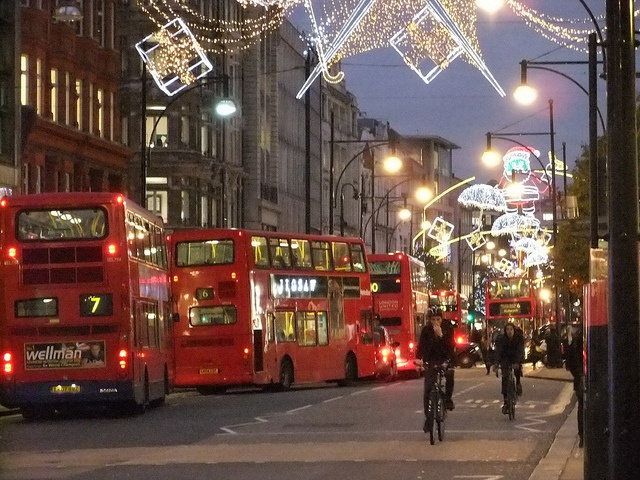Describe the objects in this image and their specific colors. I can see bus in black, maroon, and brown tones, bus in black, maroon, brown, and olive tones, bus in black, brown, and maroon tones, bus in black, maroon, gray, and brown tones, and people in black, maroon, gray, and brown tones in this image. 